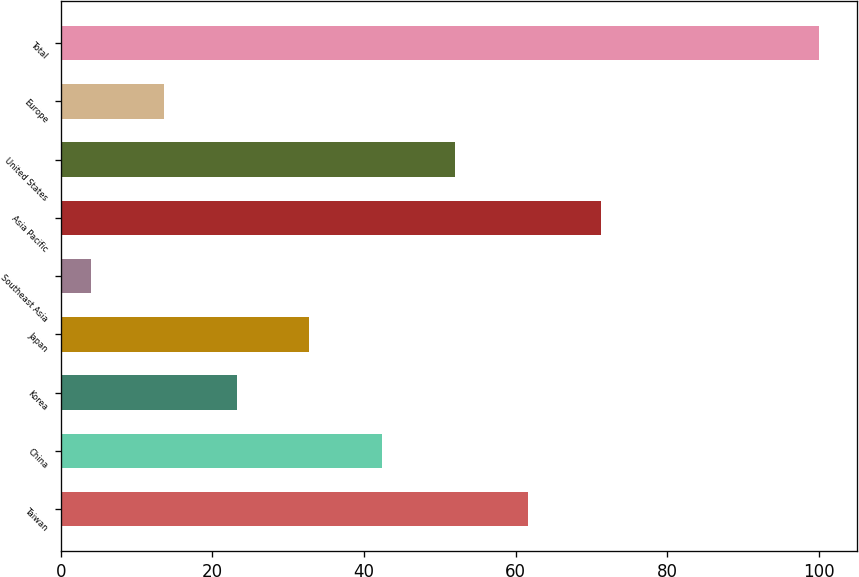Convert chart. <chart><loc_0><loc_0><loc_500><loc_500><bar_chart><fcel>Taiwan<fcel>China<fcel>Korea<fcel>Japan<fcel>Southeast Asia<fcel>Asia Pacific<fcel>United States<fcel>Europe<fcel>Total<nl><fcel>61.6<fcel>42.4<fcel>23.2<fcel>32.8<fcel>4<fcel>71.2<fcel>52<fcel>13.6<fcel>100<nl></chart> 